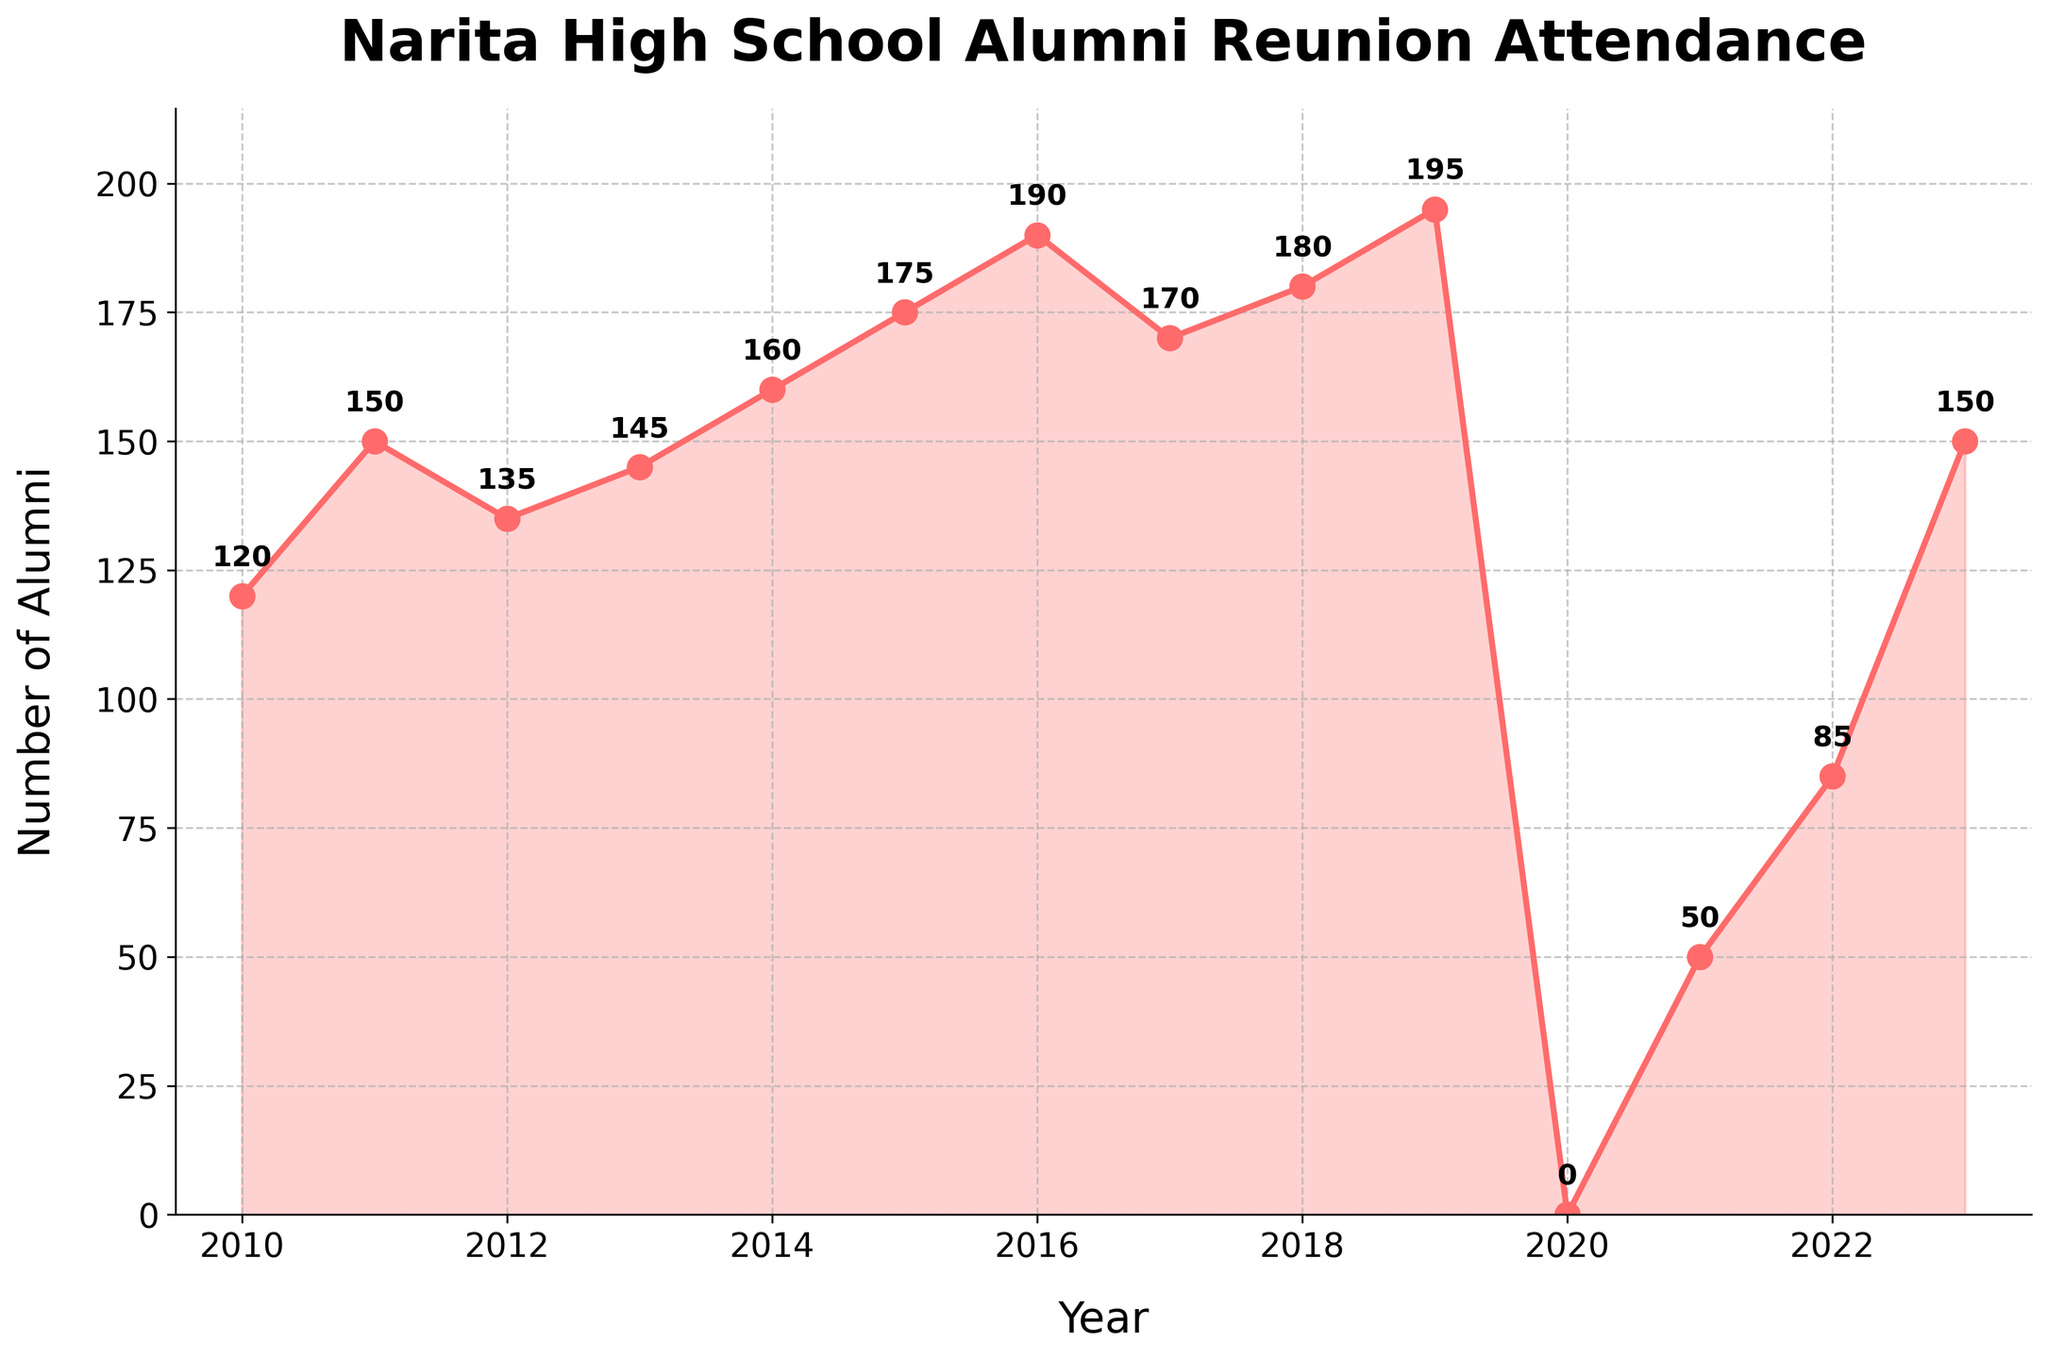What is the title of the plot? The title of the plot is found at the top of the figure, prominently displayed.
Answer: Narita High School Alumni Reunion Attendance What is the highest number of alumni attendees, and in which year did it occur? The highest peak on the plot is at 2019, where the y-axis value is 195.
Answer: 195, in 2019 How many years did the alumni attendance decrease compared to the previous year? Identify the years where the line slopes downward from the previous point: 2012, 2017, and 2020-2021.
Answer: 4 years What is the approximate average alumni attendance from 2010 to 2019? Sum the attendance values from 2010 to 2019 and divide by the number of years: (120 + 150 + 135 + 145 + 160 + 175 + 190 + 170 + 180 + 195) / 10 = 1620 / 10.
Answer: 162 Why is there a significant drop in attendance in 2020? The year 2020 shows zero attendance, likely due to an external factor such as the COVID-19 pandemic.
Answer: COVID-19 pandemic How did the attendance change from 2021 to 2022? Compare the two values in the figure for these years. Attendance in 2021 was 50, and in 2022 it increased to 85, a difference of 35.
Answer: Increased by 35 What is the trend in alumni attendance from 2010 to 2023? The general trend shows a rise from 2010 to 2019, a sharp decline in 2020, followed by a gradual recovery.
Answer: Upward with exceptions Which two consecutive years had the largest increase in attendance? Compare the differences between each pair of consecutive years (2013-2014, 2014-2015, etc.). The largest increase is from 2022 (85) to 2023 (150), which is 65.
Answer: 2022 to 2023 From 2015 to 2016, how much did the attendance increase? Subtract the value of 2015 from 2016: 190 - 175 = 15.
Answer: 15 What is the overall trend if you exclude 2020 and 2021? Without the 2020-2021 anomaly, the general trend from 2010 to 2019 and 2022-2023 shows an overall increase.
Answer: Increasing 